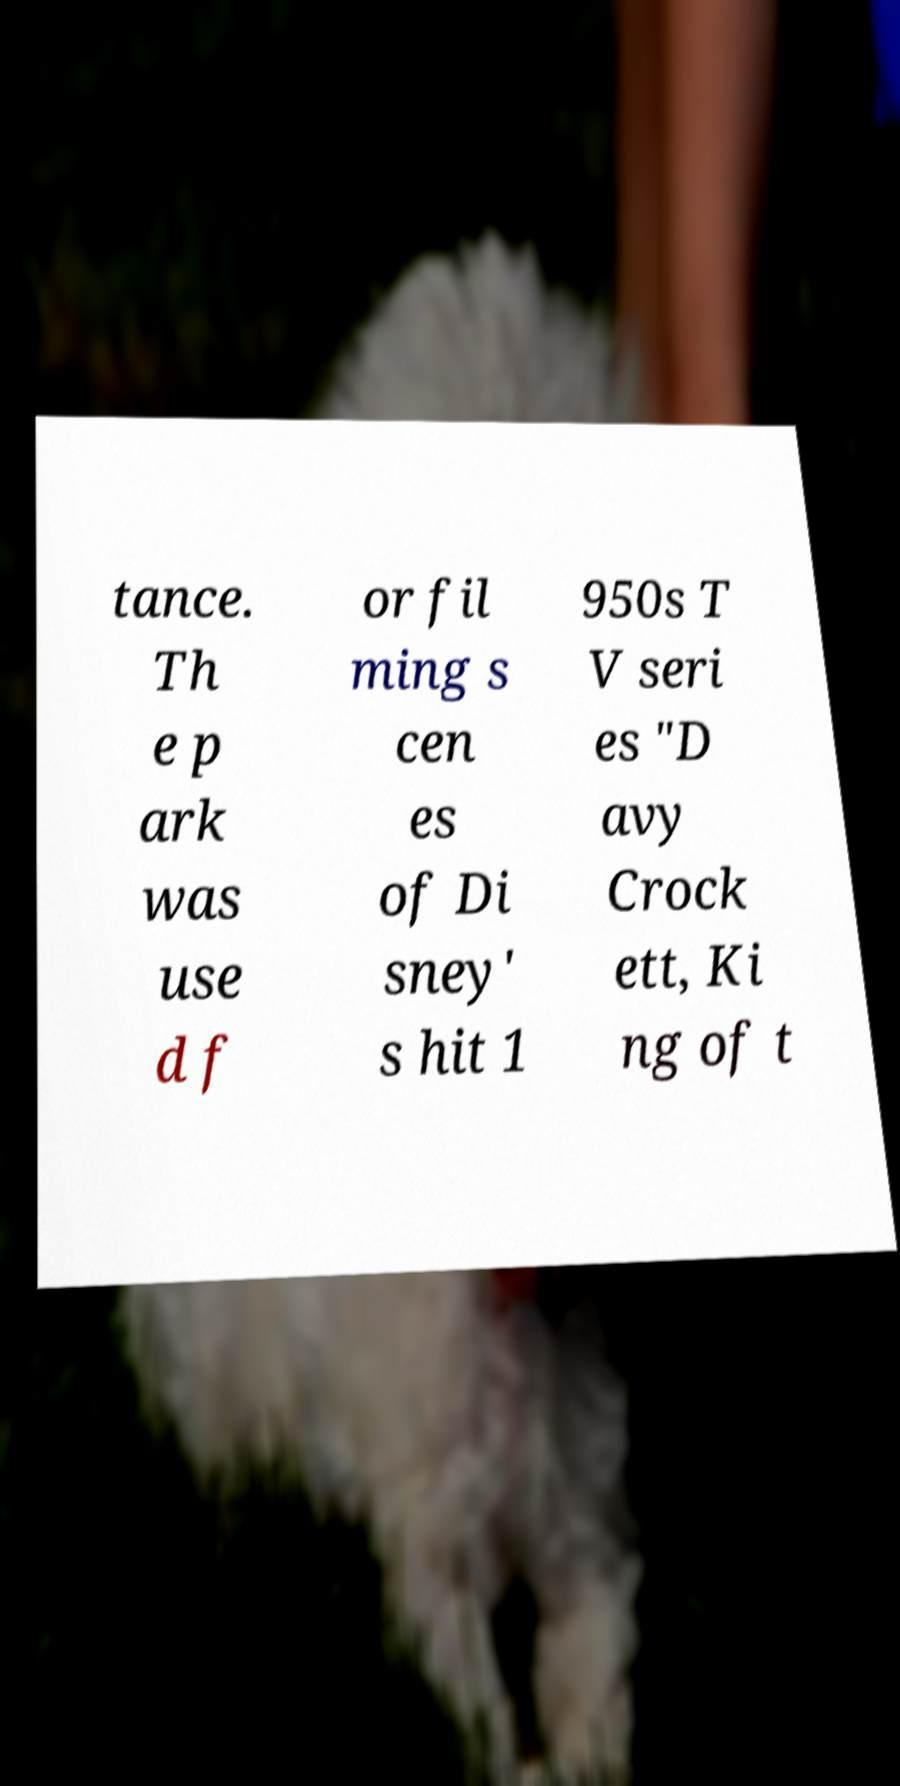For documentation purposes, I need the text within this image transcribed. Could you provide that? tance. Th e p ark was use d f or fil ming s cen es of Di sney' s hit 1 950s T V seri es "D avy Crock ett, Ki ng of t 